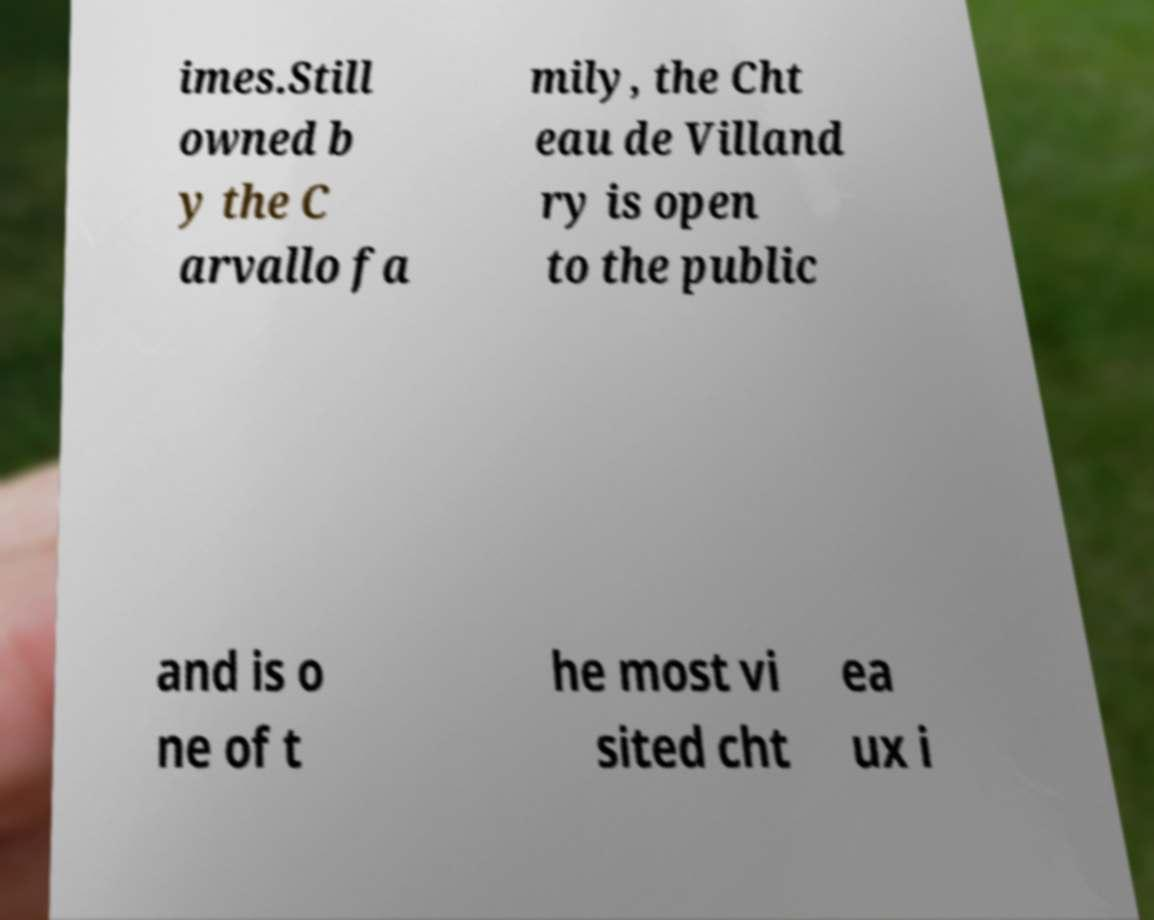Can you read and provide the text displayed in the image?This photo seems to have some interesting text. Can you extract and type it out for me? imes.Still owned b y the C arvallo fa mily, the Cht eau de Villand ry is open to the public and is o ne of t he most vi sited cht ea ux i 